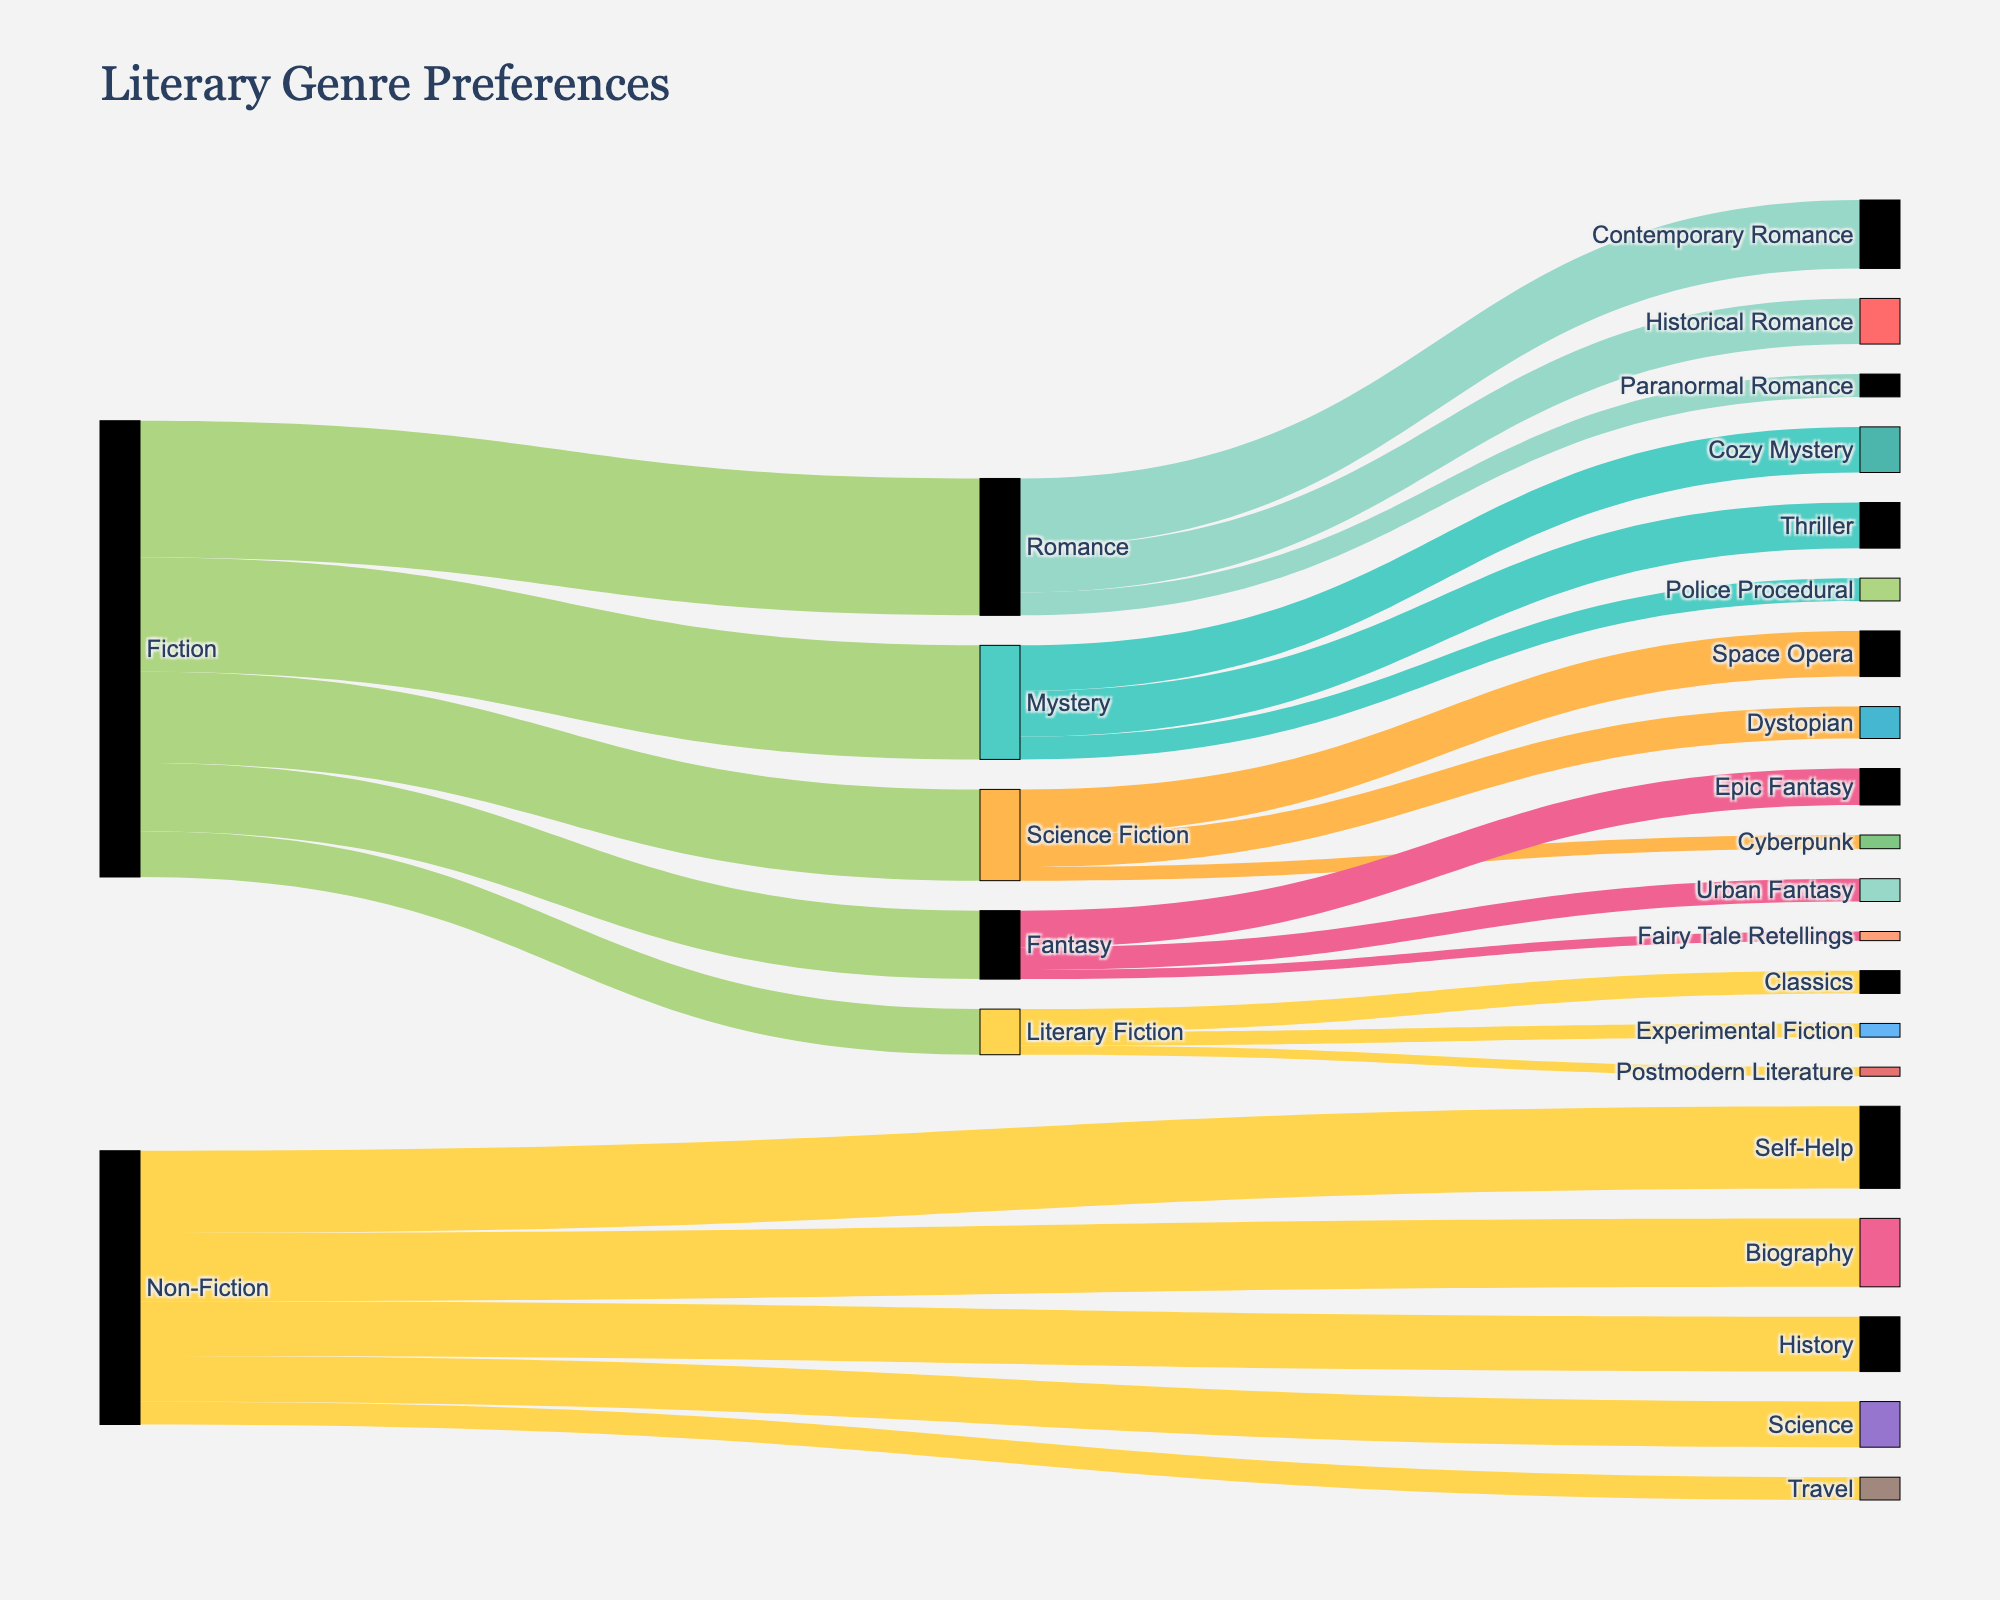How many main literary genres are there? The Sankey diagram has node labels representing different literary genres. By counting the unique main genres (nodes without any subgenres connected to them), we find that there are two main genres: Fiction and Non-Fiction.
Answer: 2 Which subgenre has the highest preference in the Romance category? In the Romance category, the Sankey diagram shows three subgenres: Contemporary Romance, Historical Romance, and Paranormal Romance. By looking at the values attached to each subgenre, the highest value (15) is for Contemporary Romance.
Answer: Contemporary Romance What is the total number of readers who prefer Fiction? To find the total number of readers who prefer Fiction, we add up the values flowing from the Fiction node to its subgenres (Romance, Mystery, Science Fiction, Fantasy, Literary Fiction): 30 + 25 + 20 + 15 + 10 = 100.
Answer: 100 What is more preferred, Science Fiction within Fiction or History within Non-Fiction? To compare the preferences, we look at the values in the Sankey diagram. The value for Science Fiction within Fiction is 20, and the value for History within Non-Fiction is 12. Therefore, Science Fiction within Fiction is more preferred.
Answer: Science Fiction How do the values of Epic Fantasy and Urban Fantasy compare? In the Sankey diagram, Epic Fantasy has a value of 8 and Urban Fantasy has a value of 5. Therefore, Epic Fantasy is preferred over Urban Fantasy.
Answer: Epic Fantasy What percentage of Non-Fiction readers prefer Self-Help? First, find the total number of Non-Fiction readers by summing the values for all Non-Fiction subgenres: 18 (Self-Help) + 15 (Biography) + 12 (History) + 10 (Science) + 5 (Travel) = 60. Then, calculate the percentage of Self-Help readers: (18 / 60) * 100 = 30%.
Answer: 30% Which has fewer readers, Cyberpunk in Science Fiction or Fairy Tale Retellings in Fantasy? In the Sankey diagram, Cyberpunk has a value of 3, while Fairy Tale Retellings has a value of 2. Therefore, Fairy Tale Retellings in Fantasy has fewer readers.
Answer: Fairy Tale Retellings What is the combined preference value for all Mystery subgenres? To find the combined preference value for all Mystery subgenres, add up the values for Cozy Mystery, Thriller, and Police Procedural: 10 + 10 + 5 = 25.
Answer: 25 Between the subgenres of Literary Fiction, which one has the lowest preference? Within the Literary Fiction category, there are three subgenres: Classics (5), Experimental Fiction (3), and Postmodern Literature (2). Postmodern Literature has the lowest preference value.
Answer: Postmodern Literature What is the total preference value for all genres and subgenres in the diagram? To find the total preference value, sum up all the values in the Sankey diagram: 30 (Romance) + 25 (Mystery) + 20 (Science Fiction) + 15 (Fantasy) + 10 (Literary Fiction) + 18 (Self-Help) + 15 (Biography) + 12 (History) + 10 (Science) + 5 (Travel) + 15 (Contemporary Romance) + 10 (Historical Romance) + 5 (Paranormal Romance) + 10 (Cozy Mystery) + 10 (Thriller) + 5 (Police Procedural) + 10 (Space Opera) + 7 (Dystopian) + 3 (Cyberpunk) + 8 (Epic Fantasy) + 5 (Urban Fantasy) + 2 (Fairy Tale Retellings) + 5 (Classics) + 3 (Experimental Fiction) + 2 (Postmodern Literature) = 290.
Answer: 290 